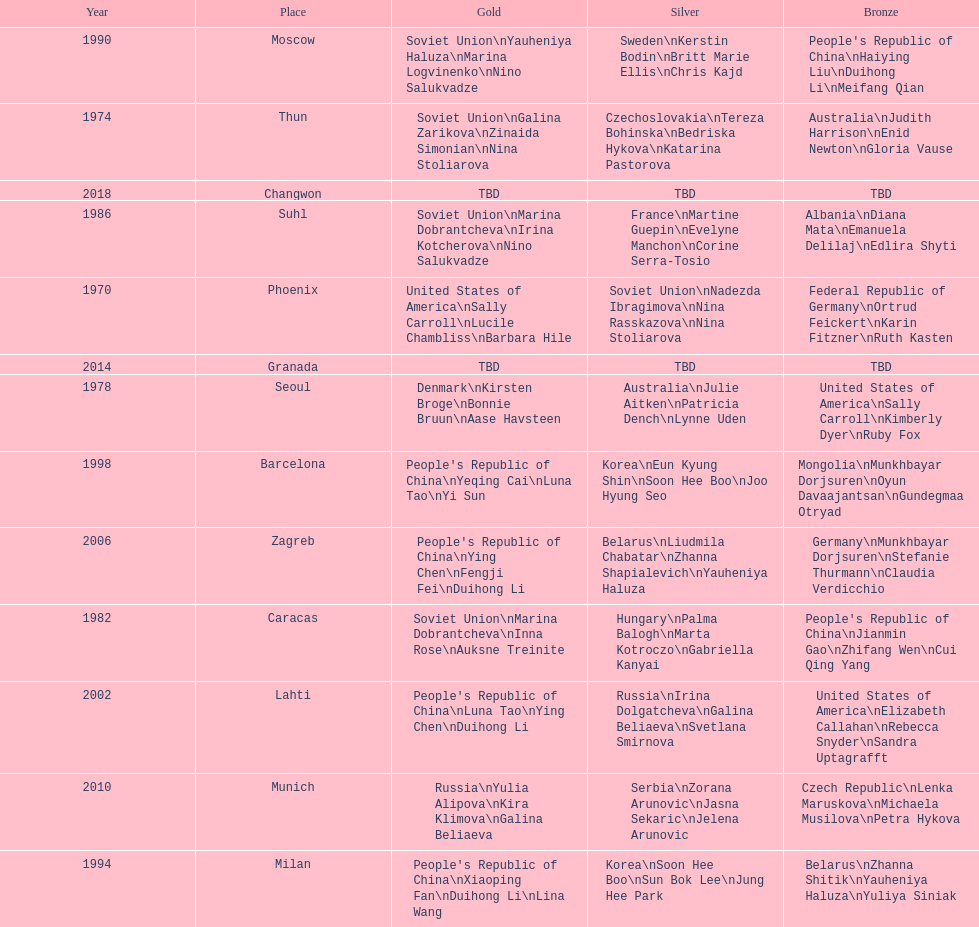What are the total number of times the soviet union is listed under the gold column? 4. 